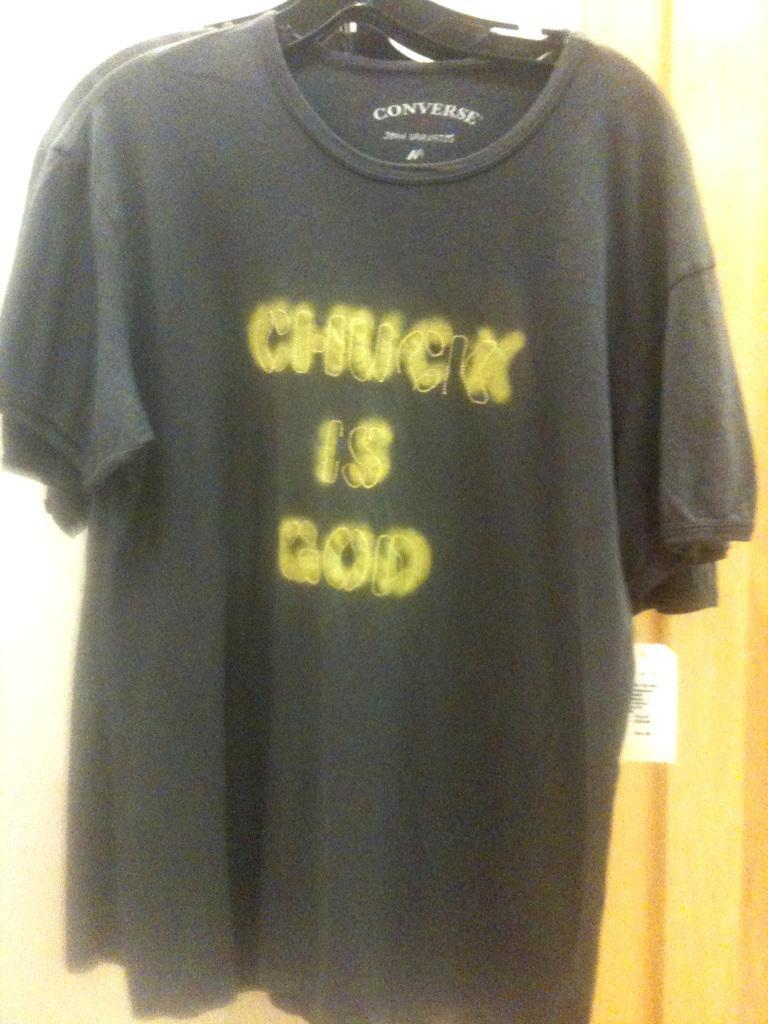In one or two sentences, can you explain what this image depicts? As we can see in the image there are black color t shirts hanged to a hanger. 